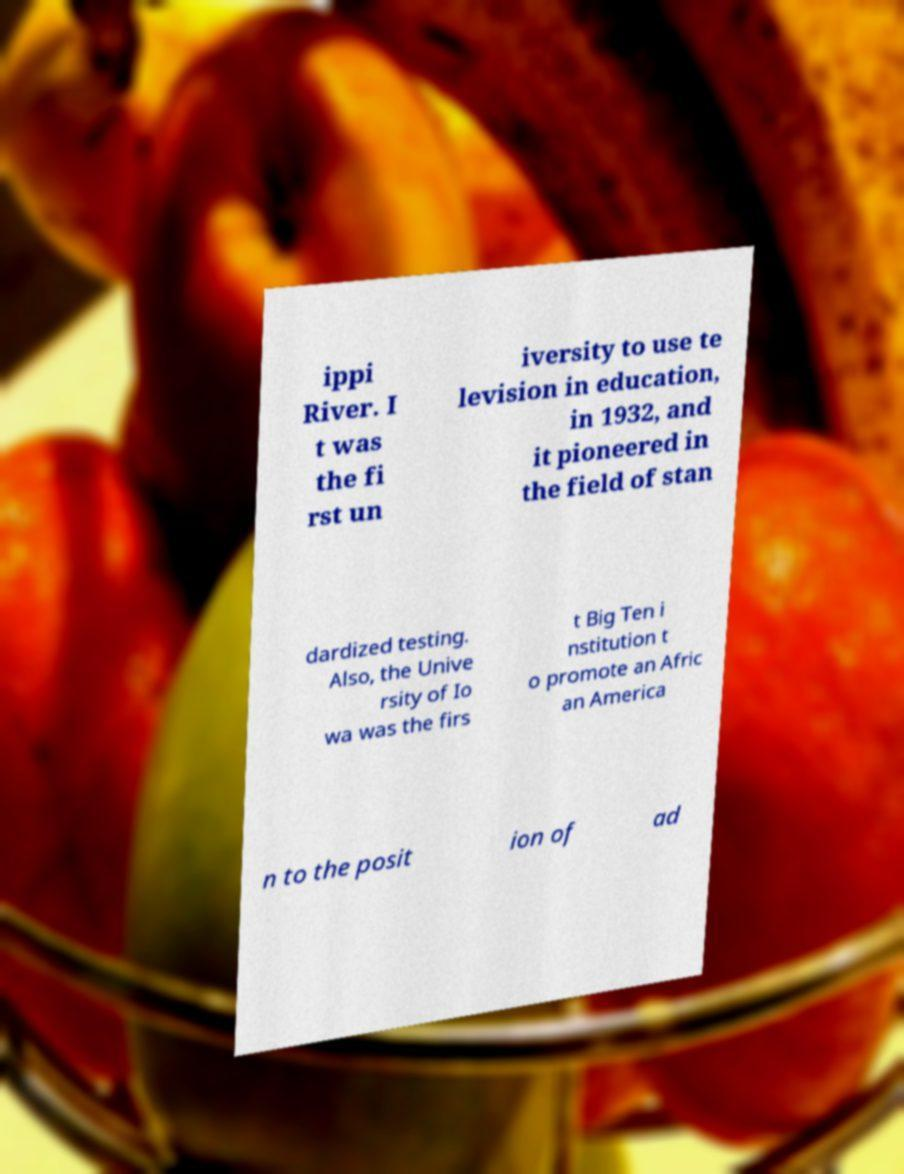For documentation purposes, I need the text within this image transcribed. Could you provide that? ippi River. I t was the fi rst un iversity to use te levision in education, in 1932, and it pioneered in the field of stan dardized testing. Also, the Unive rsity of Io wa was the firs t Big Ten i nstitution t o promote an Afric an America n to the posit ion of ad 